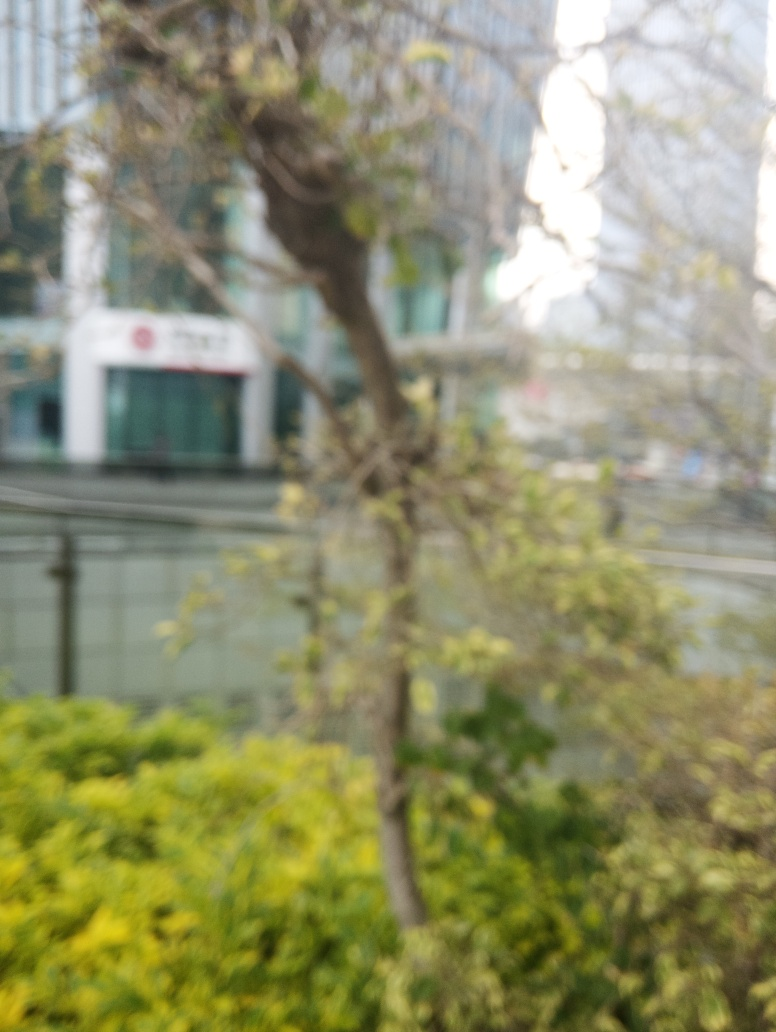Are there any discernible activities or objects in this scene that indicate the time of year or day? While specifics are hard to make out due to the blurriness, there is a general brightness and lack of shadows that could hint at an overcast day, possibly during midday. There are no clear signs of seasonal decorations or weather-related cues like snow or fallen leaves that might offer a clue about the time of year. Could you suggest how this image might have been purposefully used artistically? Artistically, the blur effect in this image can evoke a sense of movement, dynamism, or transition. It can also convey a dreamlike or nostalgic atmosphere, diverting the viewer's focus from the details of the subject matter to the overall mood or emotional tone of the scene. 